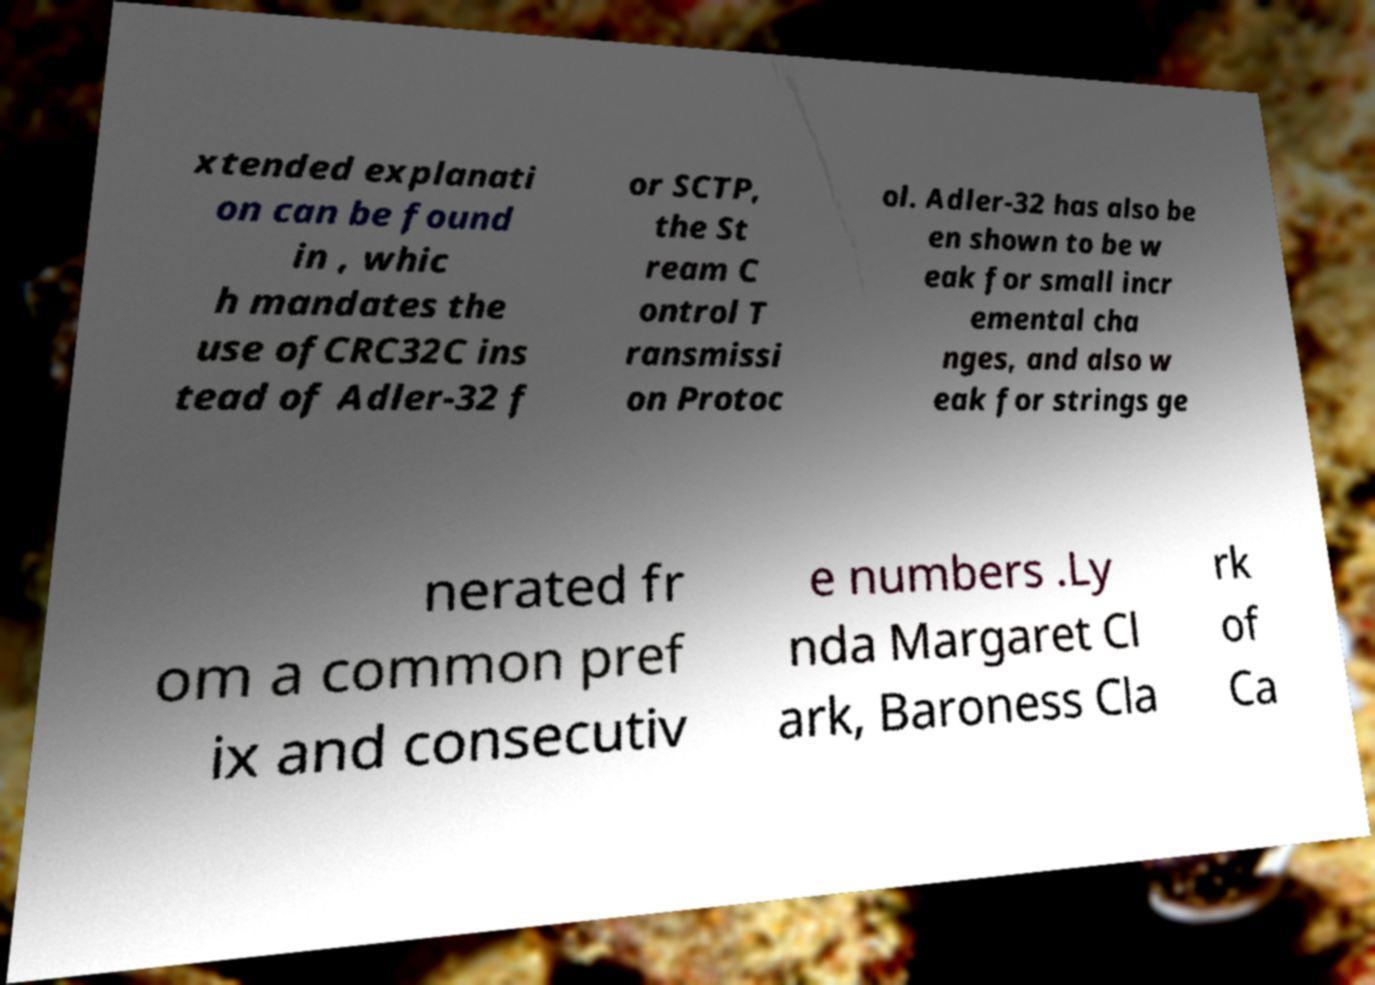Can you accurately transcribe the text from the provided image for me? xtended explanati on can be found in , whic h mandates the use ofCRC32C ins tead of Adler-32 f or SCTP, the St ream C ontrol T ransmissi on Protoc ol. Adler-32 has also be en shown to be w eak for small incr emental cha nges, and also w eak for strings ge nerated fr om a common pref ix and consecutiv e numbers .Ly nda Margaret Cl ark, Baroness Cla rk of Ca 